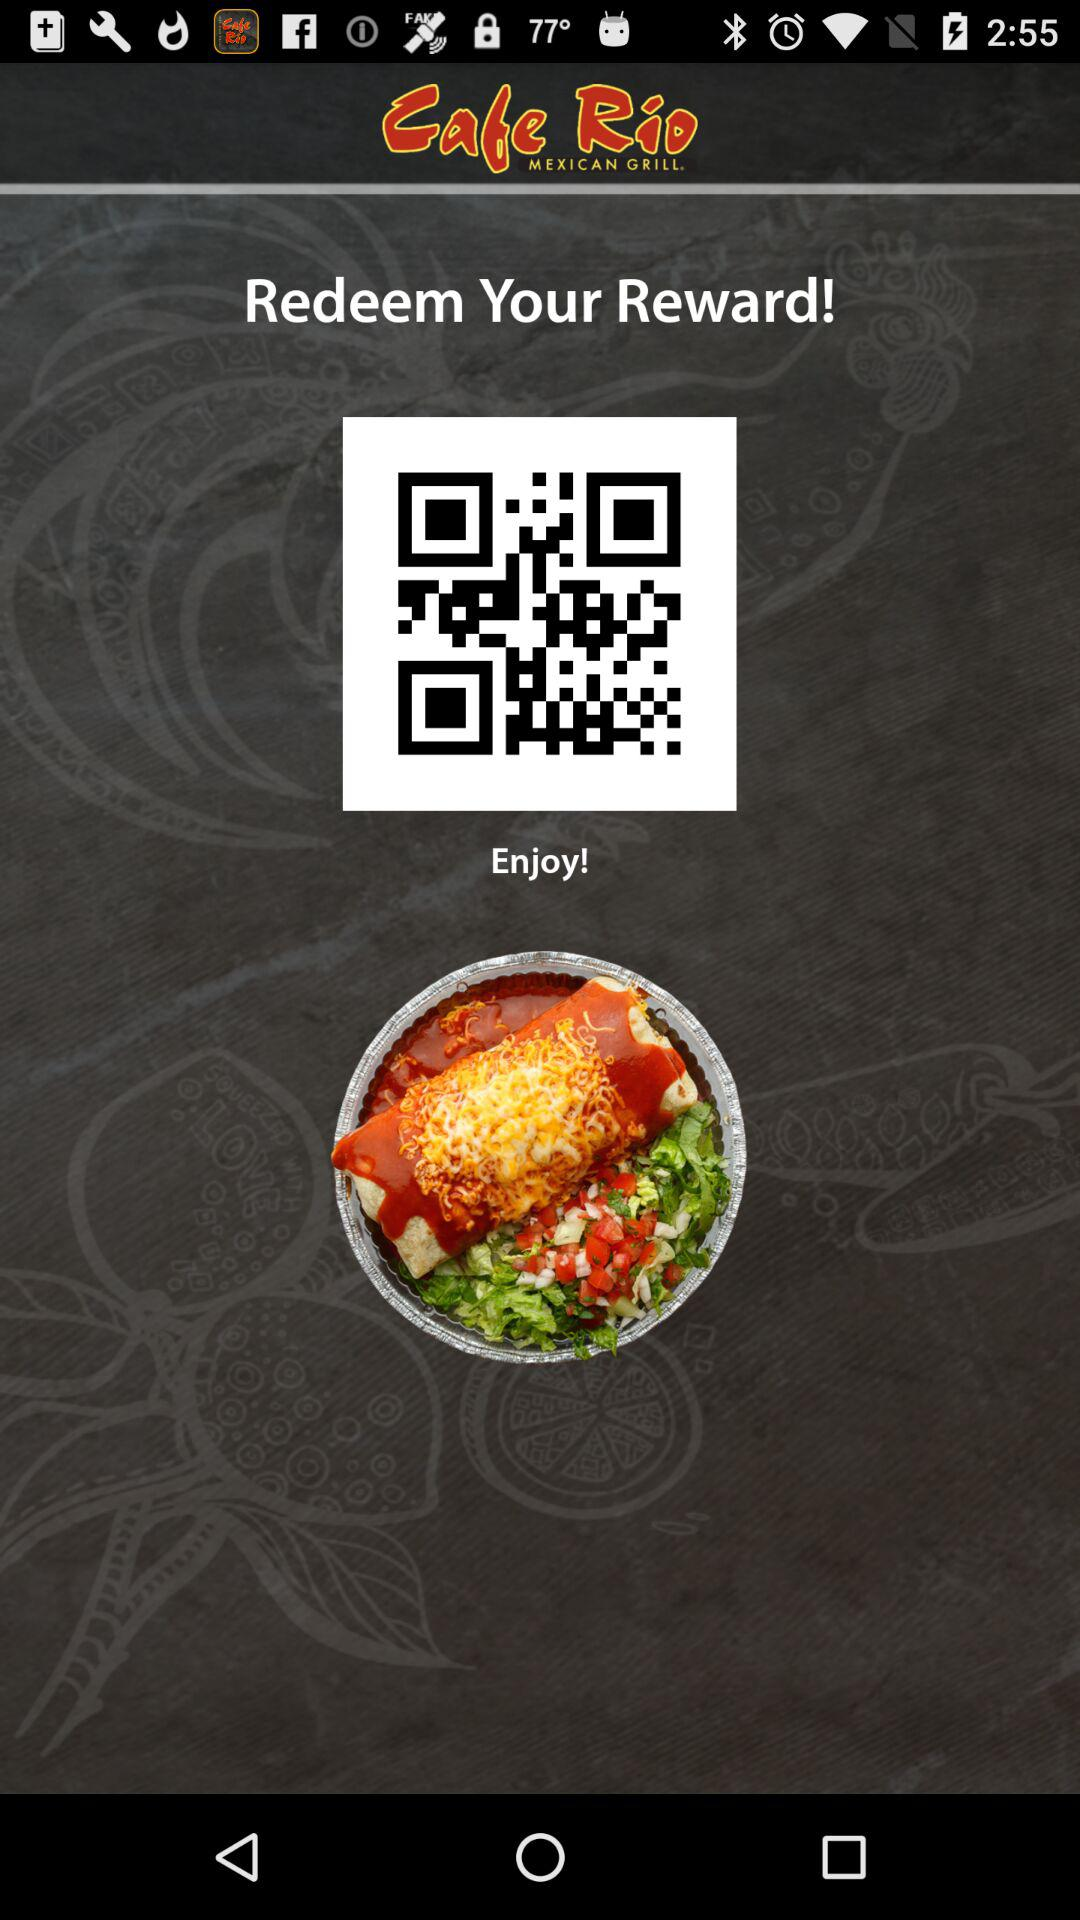What is the name of the application? The name of the application is "Cafe Rio". 